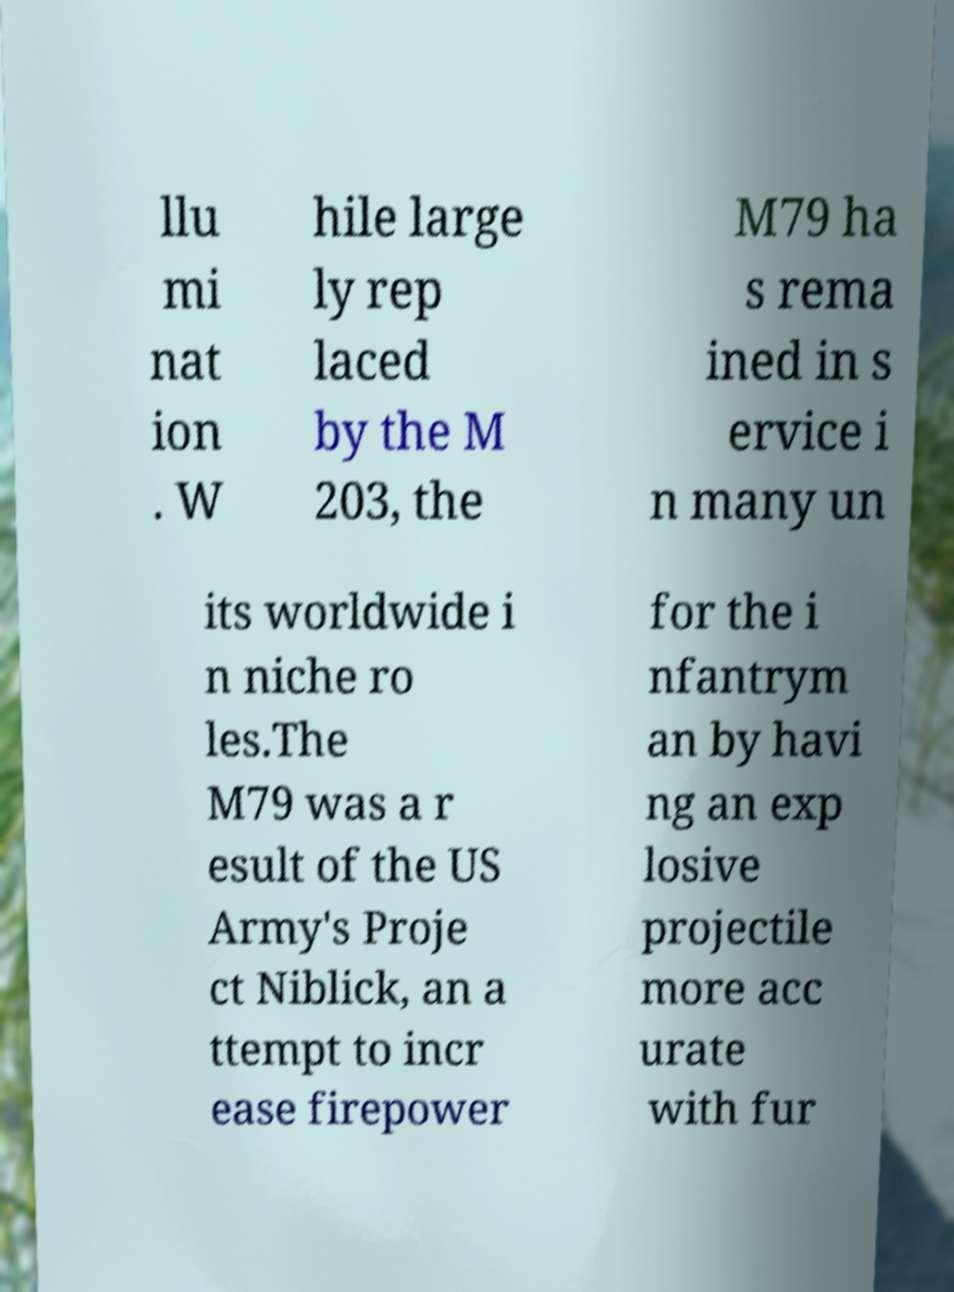Please read and relay the text visible in this image. What does it say? llu mi nat ion . W hile large ly rep laced by the M 203, the M79 ha s rema ined in s ervice i n many un its worldwide i n niche ro les.The M79 was a r esult of the US Army's Proje ct Niblick, an a ttempt to incr ease firepower for the i nfantrym an by havi ng an exp losive projectile more acc urate with fur 